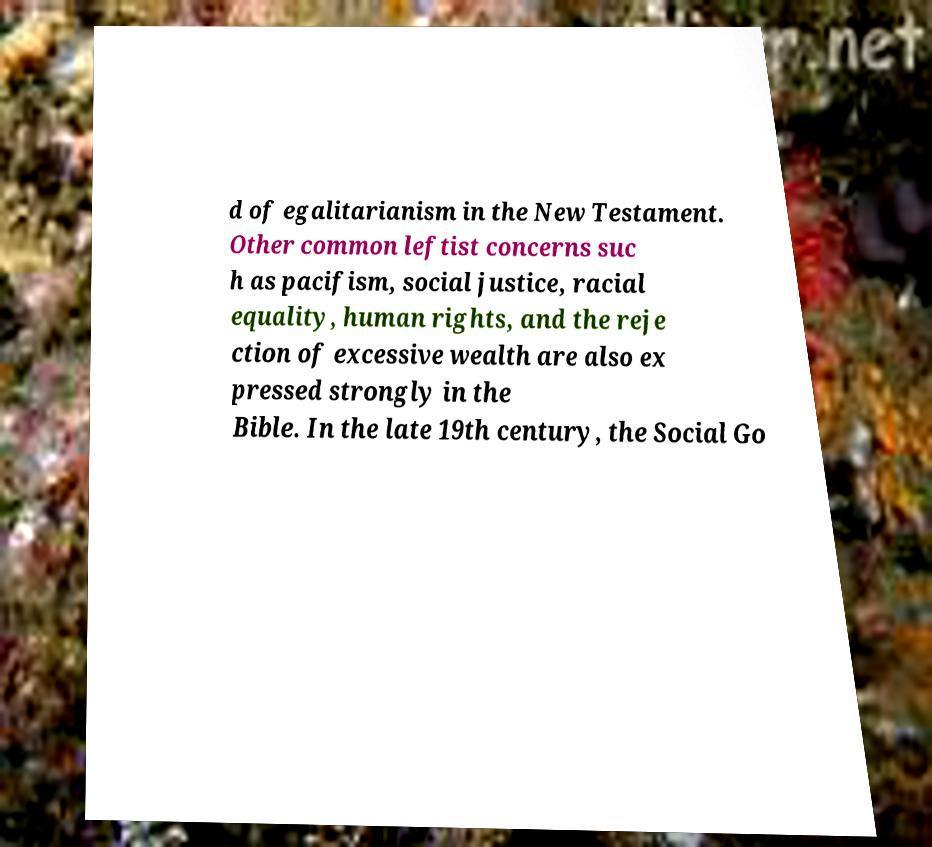For documentation purposes, I need the text within this image transcribed. Could you provide that? d of egalitarianism in the New Testament. Other common leftist concerns suc h as pacifism, social justice, racial equality, human rights, and the reje ction of excessive wealth are also ex pressed strongly in the Bible. In the late 19th century, the Social Go 